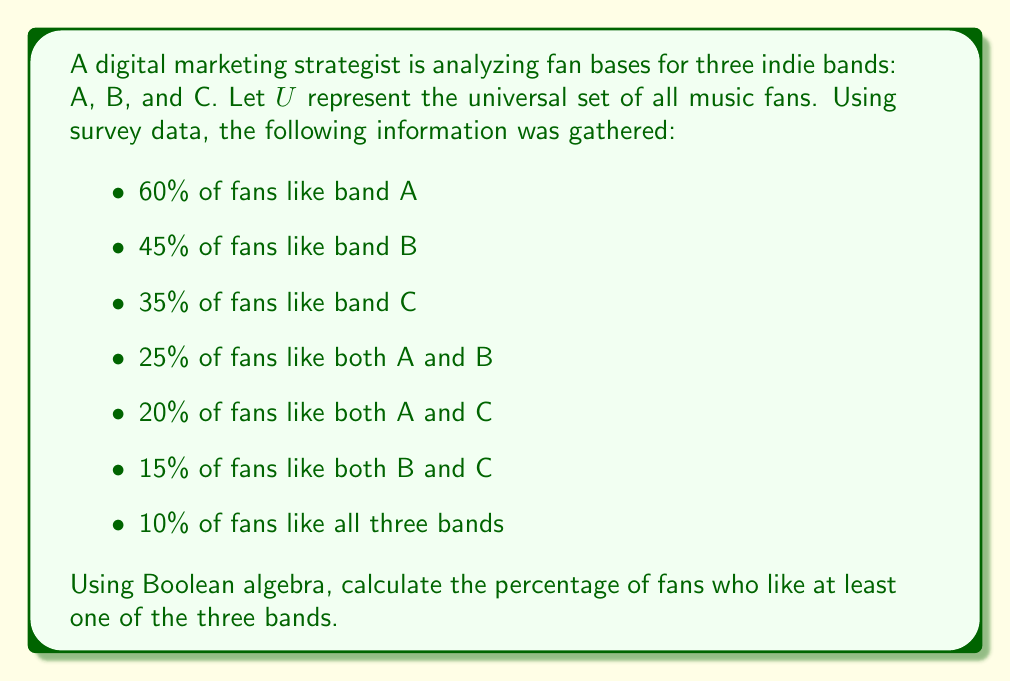Give your solution to this math problem. Let's approach this step-by-step using Boolean algebra and the inclusion-exclusion principle:

1) Let $A$, $B$, and $C$ represent the sets of fans who like bands A, B, and C respectively.

2) We want to find $P(A \cup B \cup C)$, which represents the probability of a fan liking at least one of the three bands.

3) The inclusion-exclusion principle states:

   $P(A \cup B \cup C) = P(A) + P(B) + P(C) - P(A \cap B) - P(A \cap C) - P(B \cap C) + P(A \cap B \cap C)$

4) We're given:
   $P(A) = 0.60$
   $P(B) = 0.45$
   $P(C) = 0.35$
   $P(A \cap B) = 0.25$
   $P(A \cap C) = 0.20$
   $P(B \cap C) = 0.15$
   $P(A \cap B \cap C) = 0.10$

5) Substituting these values into the equation:

   $P(A \cup B \cup C) = 0.60 + 0.45 + 0.35 - 0.25 - 0.20 - 0.15 + 0.10$

6) Calculating:

   $P(A \cup B \cup C) = 0.90$

7) Converting to a percentage:

   $0.90 * 100\% = 90\%$

Therefore, 90% of fans like at least one of the three bands.
Answer: 90% 